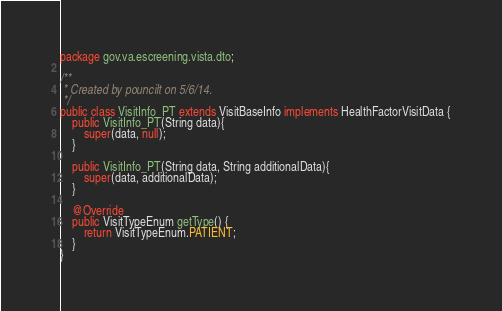<code> <loc_0><loc_0><loc_500><loc_500><_Java_>package gov.va.escreening.vista.dto;

/**
 * Created by pouncilt on 5/6/14.
 */
public class VisitInfo_PT extends VisitBaseInfo implements HealthFactorVisitData {
    public VisitInfo_PT(String data){
        super(data, null);
    }

    public VisitInfo_PT(String data, String additionalData){
        super(data, additionalData);
    }

    @Override
    public VisitTypeEnum getType() {
        return VisitTypeEnum.PATIENT;
    }
}
</code> 